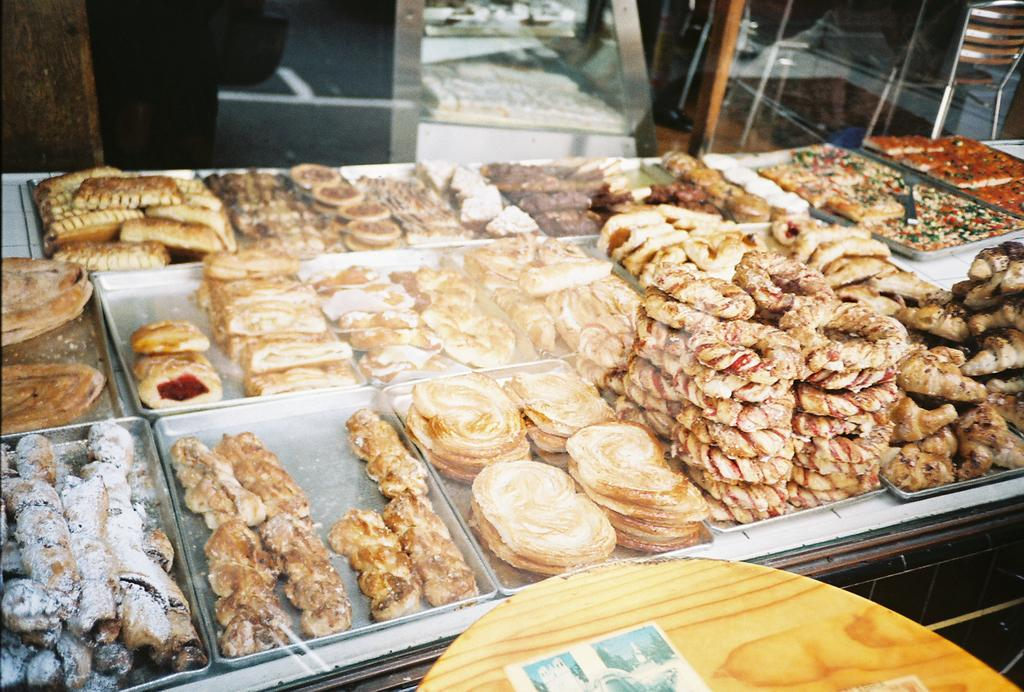What is present on the table in the image? There are food items in trays on the table. Where is the table located in the image? The table is visible at the bottom of the image. What type of arch can be seen in the background of the image? There is no arch present in the background of the image. How many flies are visible on the food items in the image? There are no flies visible on the food items in the image. 